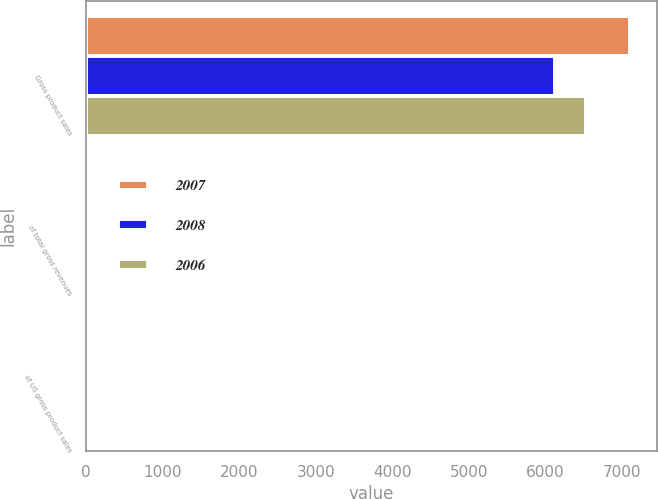<chart> <loc_0><loc_0><loc_500><loc_500><stacked_bar_chart><ecel><fcel>Gross product sales<fcel>of total gross revenues<fcel>of US gross product sales<nl><fcel>2007<fcel>7099<fcel>37<fcel>46<nl><fcel>2008<fcel>6124<fcel>31<fcel>39<nl><fcel>2006<fcel>6523<fcel>35<fcel>42<nl></chart> 